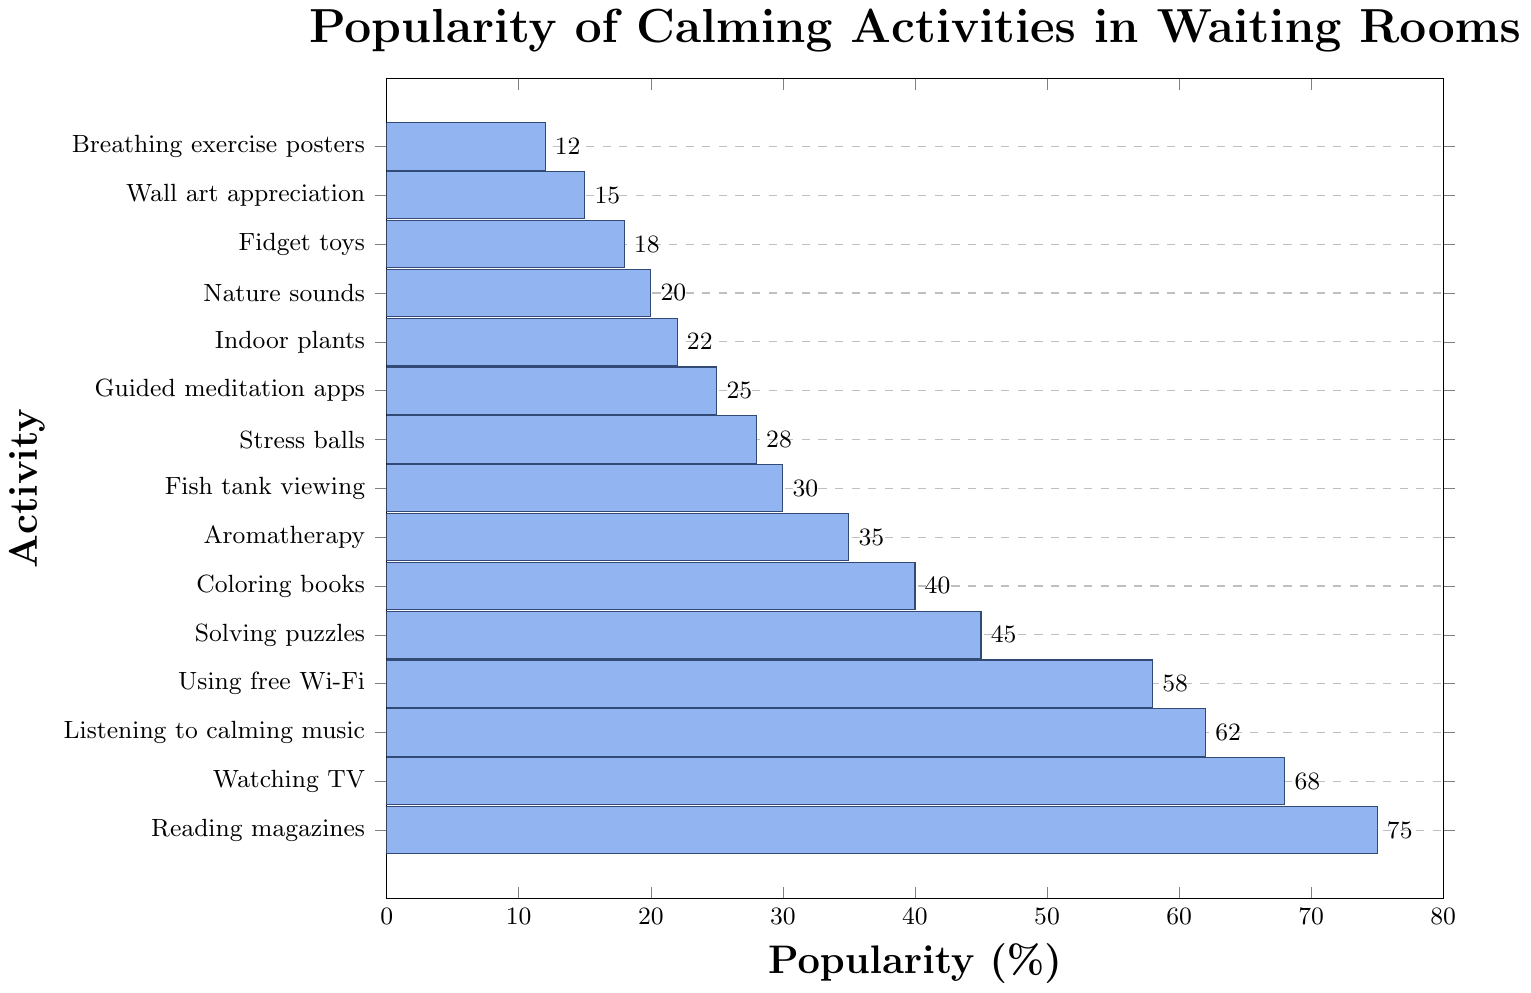What is the most popular calming activity in the waiting room? The bar representing "Reading magazines" is the tallest, indicating it has the highest popularity percentage.
Answer: Reading magazines Which activity has a higher popularity: Watching TV or Listening to calming music? By comparing the lengths of the bars, "Watching TV" has a greater length than "Listening to calming music."
Answer: Watching TV How many activities have a popularity of 50% or more? The activities with 50% or more popularity are "Reading magazines," "Watching TV," "Listening to calming music," and "Using free Wi-Fi." Summing them up gives 4 activities.
Answer: 4 What is the difference in popularity between Solving puzzles and Aromatherapy? The bar for "Solving puzzles" is at 45%, and the bar for "Aromatherapy" is at 35%. The difference is 45 - 35 = 10%.
Answer: 10% Which activity is less popular: Stress balls or Fish tank viewing? The bar for "Stress balls" is shorter than the bar for "Fish tank viewing," indicating it is less popular.
Answer: Stress balls What is the average popularity of the top three most popular activities? The top three activities are "Reading magazines" (75%), "Watching TV" (68%), and "Listening to calming music" (62%). The average is (75 + 68 + 62) / 3 = 205 / 3 = 68.33%.
Answer: 68.33% Are there more activities with popularity above or below 30%? Activities above 30%: 10. Activities below 30%: 5. Therefore, there are more activities above 30%.
Answer: Above 30% What percentage point difference separates the popularity of Aromatherapy and Guided meditation apps? The percentage for Aromatherapy is 35%, and for Guided meditation apps, it is 25%. The difference is 35 - 25 = 10%.
Answer: 10% Is Indoor plants more or less popular than Nature sounds? The bar for "Indoor plants" is slightly longer than the bar for "Nature sounds," indicating it is more popular.
Answer: More popular What is the combined popularity of the least three popular activities? The least three popular activities are "Breathing exercise posters" (12%), "Wall art appreciation" (15%), and "Fidget toys" (18%). The combined popularity is 12 + 15 + 18 = 45%.
Answer: 45% 